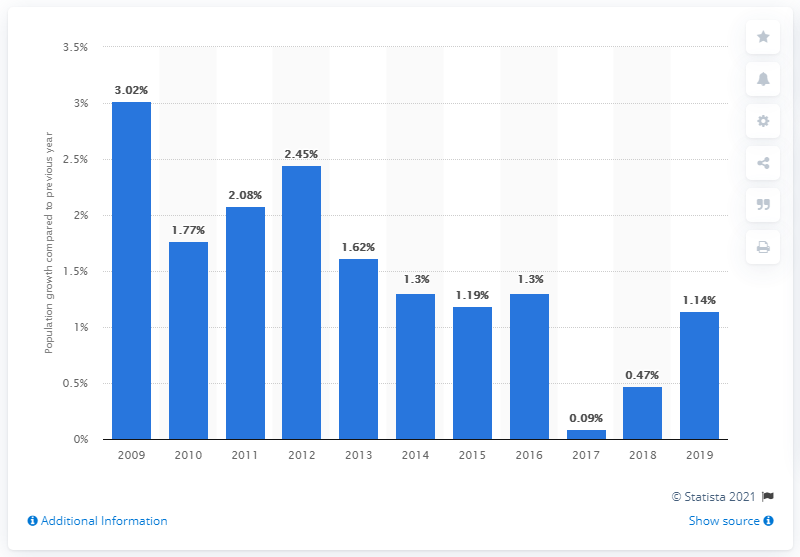List a handful of essential elements in this visual. The population of Singapore increased by 1.14% in 2019. 